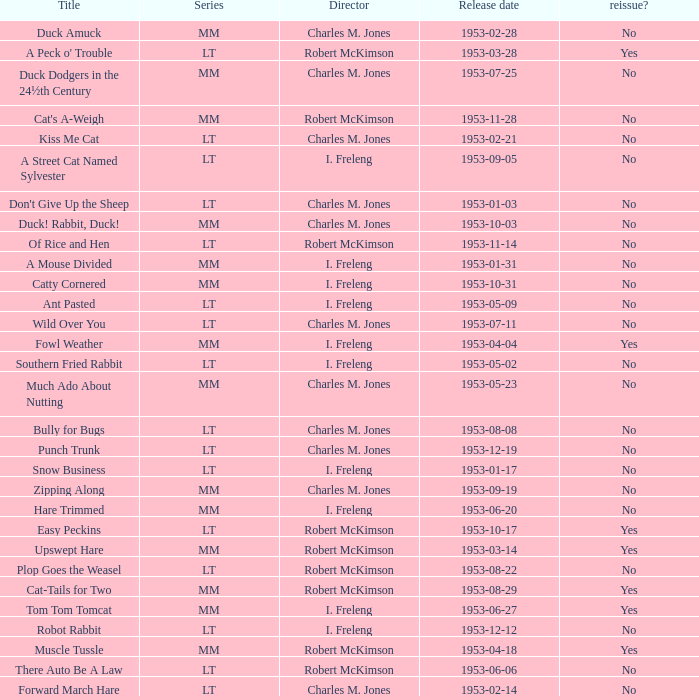What's the release date of Upswept Hare? 1953-03-14. 